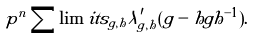Convert formula to latex. <formula><loc_0><loc_0><loc_500><loc_500>p ^ { n } \sum \lim i t s _ { g , h } \lambda _ { g , h } ^ { \prime } ( g - h g h ^ { - 1 } ) .</formula> 